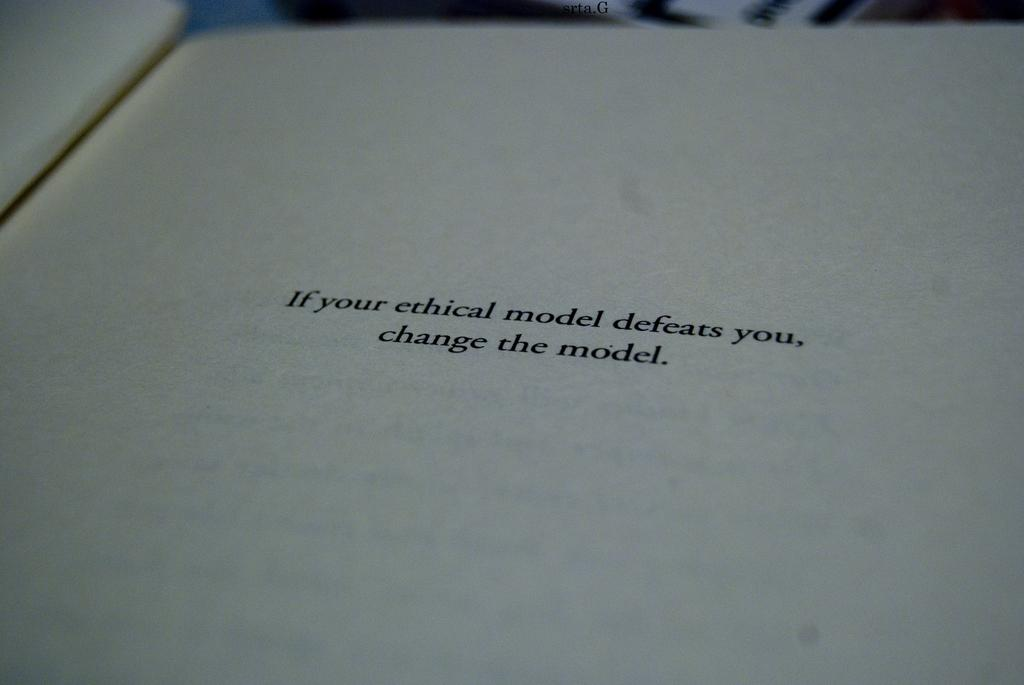<image>
Write a terse but informative summary of the picture. A notation page of a book that says if your ethical model defeats you, change the model. 